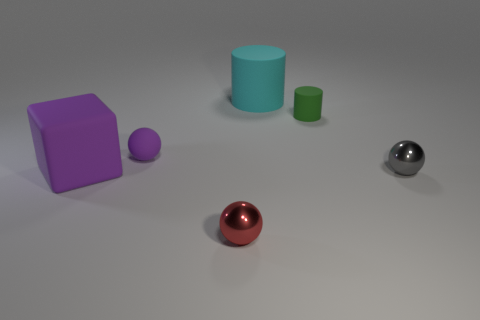Add 4 red shiny things. How many objects exist? 10 Subtract all cylinders. How many objects are left? 4 Add 1 green cylinders. How many green cylinders are left? 2 Add 1 big brown blocks. How many big brown blocks exist? 1 Subtract 0 brown blocks. How many objects are left? 6 Subtract all small blue rubber cylinders. Subtract all cubes. How many objects are left? 5 